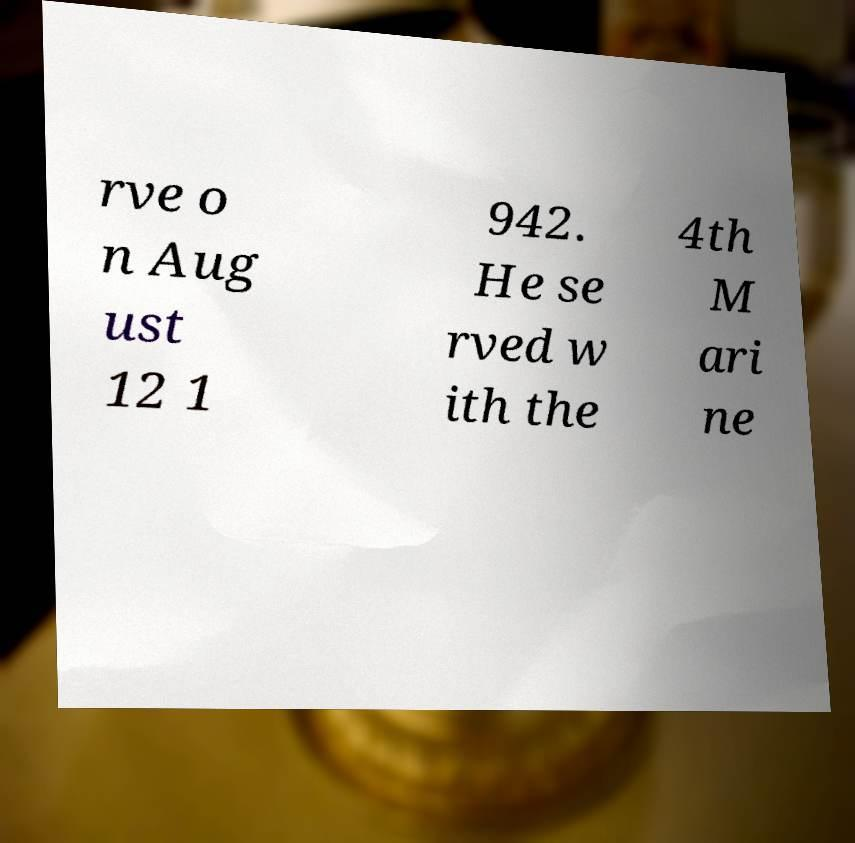Can you accurately transcribe the text from the provided image for me? rve o n Aug ust 12 1 942. He se rved w ith the 4th M ari ne 